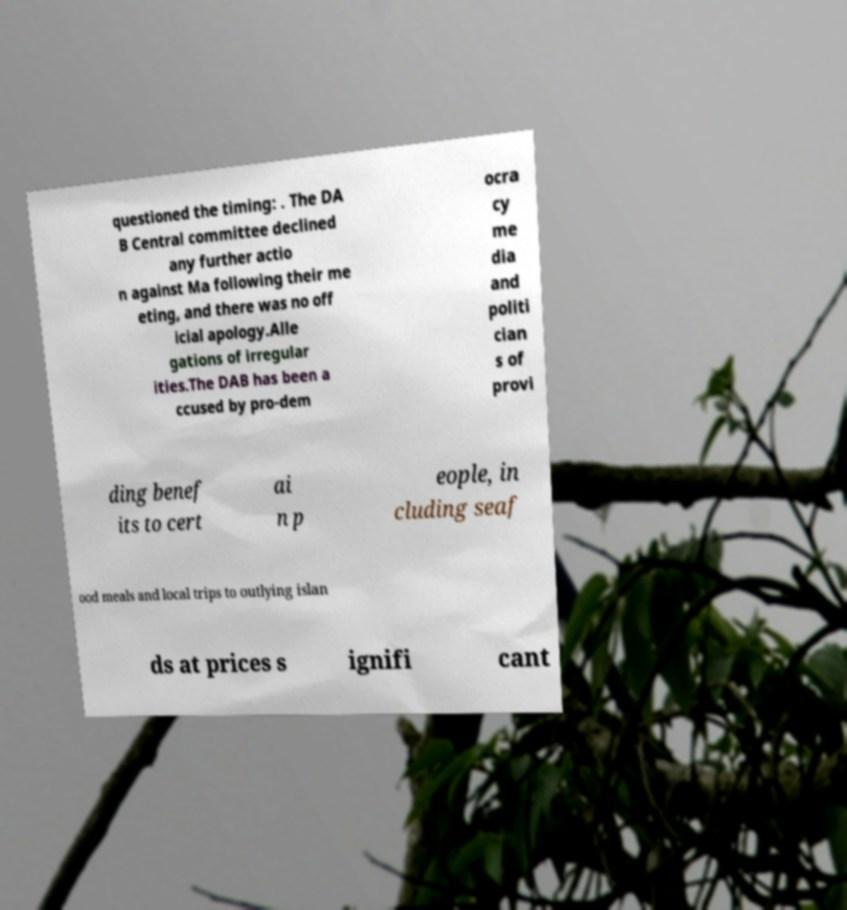Could you extract and type out the text from this image? questioned the timing: . The DA B Central committee declined any further actio n against Ma following their me eting, and there was no off icial apology.Alle gations of irregular ities.The DAB has been a ccused by pro-dem ocra cy me dia and politi cian s of provi ding benef its to cert ai n p eople, in cluding seaf ood meals and local trips to outlying islan ds at prices s ignifi cant 